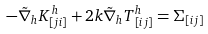Convert formula to latex. <formula><loc_0><loc_0><loc_500><loc_500>- \tilde { \nabla } _ { h } K _ { [ j i ] } ^ { \, h } + 2 k { \tilde { \nabla } } _ { h } T ^ { h } _ { \, [ i j ] } = \Sigma _ { [ i j ] }</formula> 